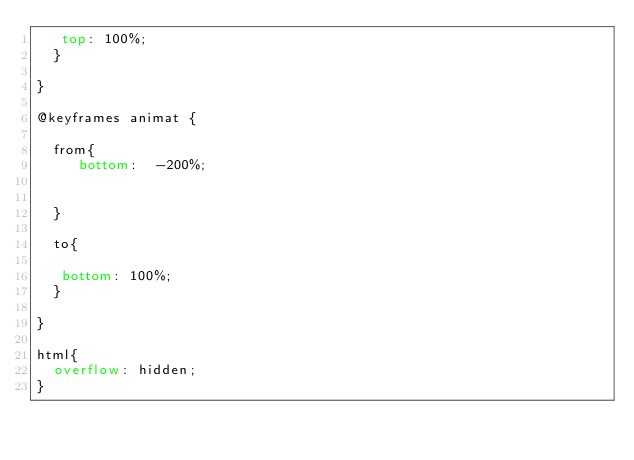<code> <loc_0><loc_0><loc_500><loc_500><_CSS_>   top: 100%;
  }

}

@keyframes animat {

  from{
     bottom:  -200%;


  }

  to{

   bottom: 100%;
  }

}

html{
  overflow: hidden;
}
</code> 